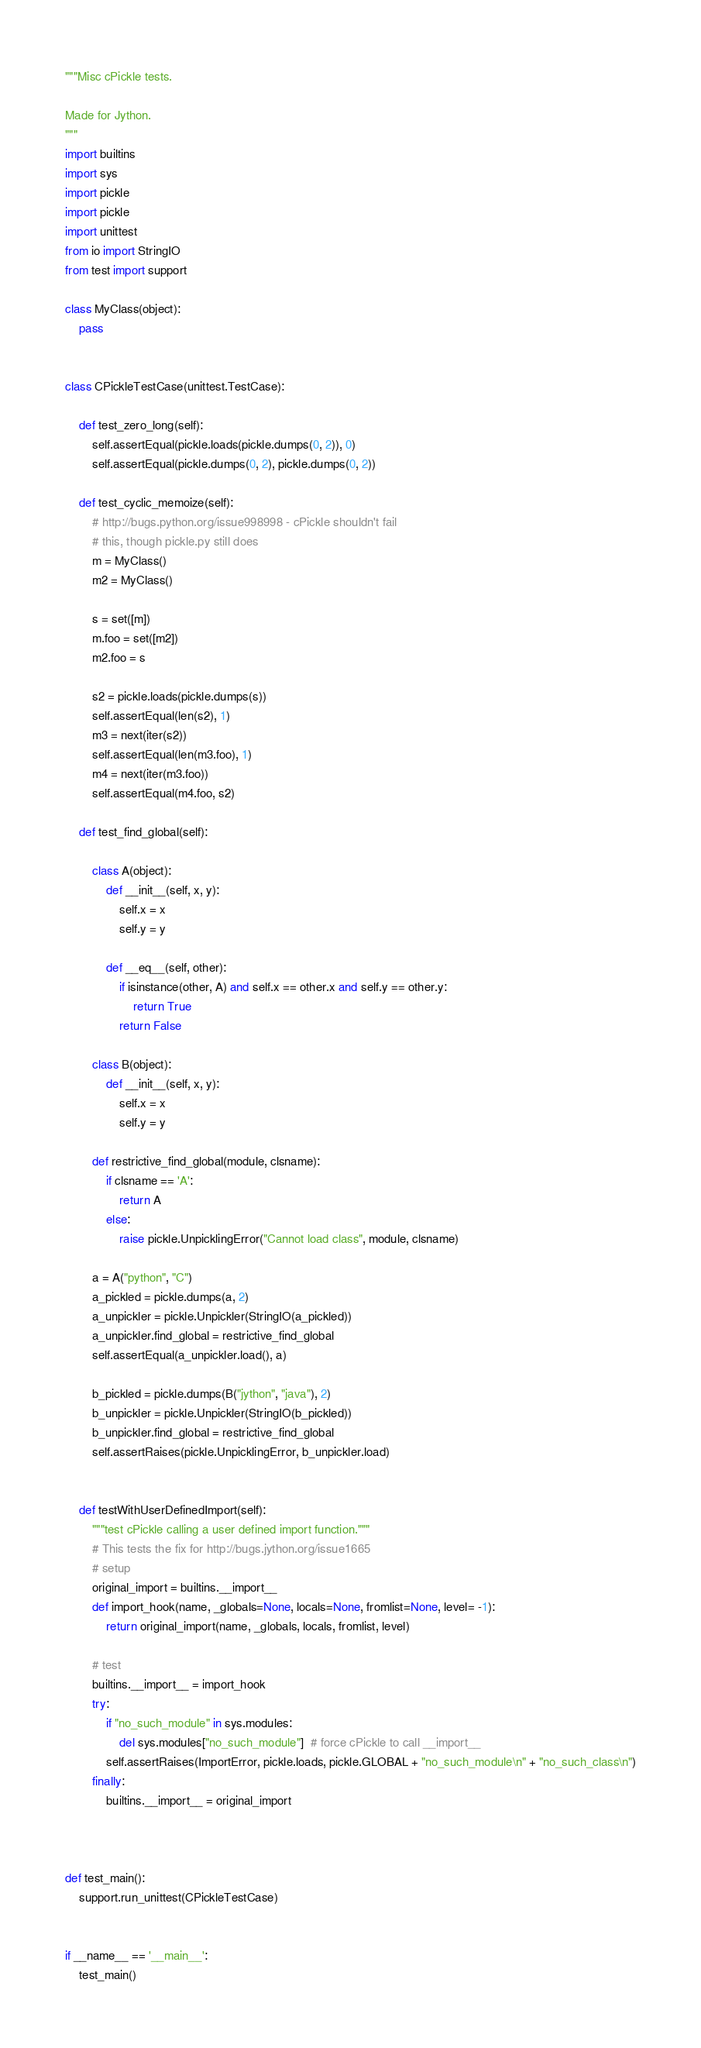<code> <loc_0><loc_0><loc_500><loc_500><_Python_>"""Misc cPickle tests.

Made for Jython.
"""
import builtins
import sys
import pickle
import pickle
import unittest
from io import StringIO
from test import support

class MyClass(object):
    pass


class CPickleTestCase(unittest.TestCase):

    def test_zero_long(self):
        self.assertEqual(pickle.loads(pickle.dumps(0, 2)), 0)
        self.assertEqual(pickle.dumps(0, 2), pickle.dumps(0, 2))

    def test_cyclic_memoize(self):
        # http://bugs.python.org/issue998998 - cPickle shouldn't fail
        # this, though pickle.py still does
        m = MyClass()
        m2 = MyClass()

        s = set([m])
        m.foo = set([m2])
        m2.foo = s

        s2 = pickle.loads(pickle.dumps(s))
        self.assertEqual(len(s2), 1)
        m3 = next(iter(s2))
        self.assertEqual(len(m3.foo), 1)
        m4 = next(iter(m3.foo))
        self.assertEqual(m4.foo, s2)

    def test_find_global(self):

        class A(object):
            def __init__(self, x, y):
                self.x = x
                self.y = y

            def __eq__(self, other):
                if isinstance(other, A) and self.x == other.x and self.y == other.y:
                    return True
                return False

        class B(object):
            def __init__(self, x, y):
                self.x = x
                self.y = y

        def restrictive_find_global(module, clsname):
            if clsname == 'A':
                return A
            else:
                raise pickle.UnpicklingError("Cannot load class", module, clsname)

        a = A("python", "C")
        a_pickled = pickle.dumps(a, 2)
        a_unpickler = pickle.Unpickler(StringIO(a_pickled))
        a_unpickler.find_global = restrictive_find_global
        self.assertEqual(a_unpickler.load(), a)

        b_pickled = pickle.dumps(B("jython", "java"), 2)
        b_unpickler = pickle.Unpickler(StringIO(b_pickled))
        b_unpickler.find_global = restrictive_find_global
        self.assertRaises(pickle.UnpicklingError, b_unpickler.load)


    def testWithUserDefinedImport(self):
        """test cPickle calling a user defined import function."""
        # This tests the fix for http://bugs.jython.org/issue1665
        # setup
        original_import = builtins.__import__
        def import_hook(name, _globals=None, locals=None, fromlist=None, level= -1):
            return original_import(name, _globals, locals, fromlist, level)
    
        # test
        builtins.__import__ = import_hook
        try:
            if "no_such_module" in sys.modules:
                del sys.modules["no_such_module"]  # force cPickle to call __import__
            self.assertRaises(ImportError, pickle.loads, pickle.GLOBAL + "no_such_module\n" + "no_such_class\n")
        finally:
            builtins.__import__ = original_import



def test_main():
    support.run_unittest(CPickleTestCase)


if __name__ == '__main__':
    test_main()
</code> 